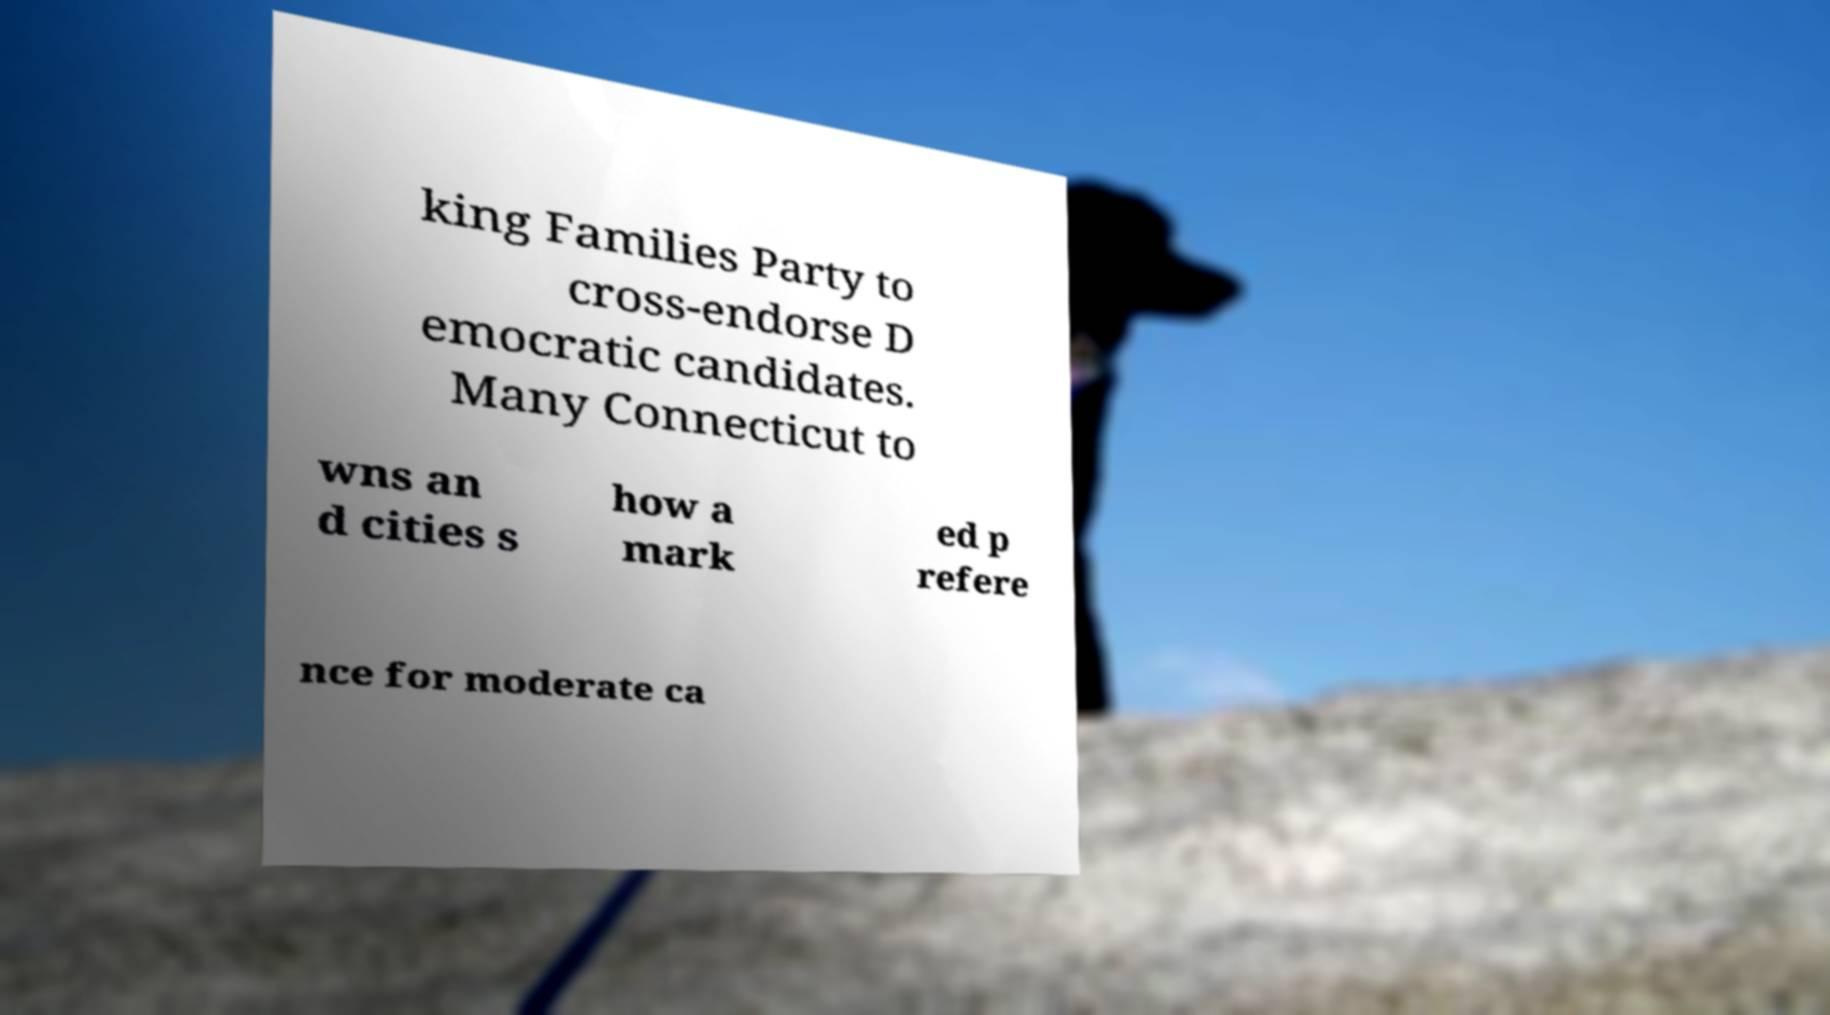Can you accurately transcribe the text from the provided image for me? king Families Party to cross-endorse D emocratic candidates. Many Connecticut to wns an d cities s how a mark ed p refere nce for moderate ca 